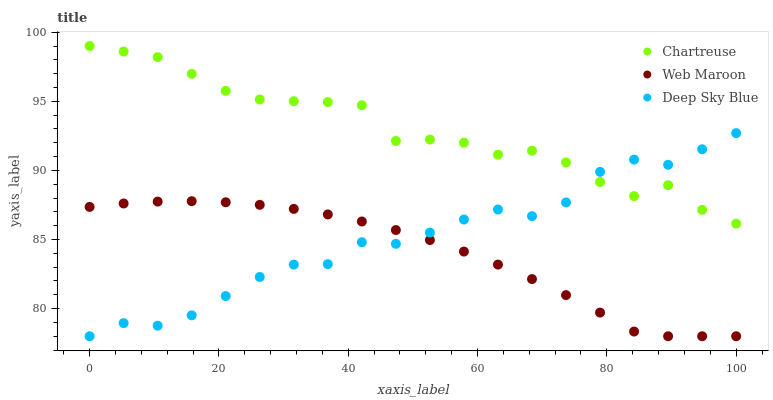Does Web Maroon have the minimum area under the curve?
Answer yes or no. Yes. Does Chartreuse have the maximum area under the curve?
Answer yes or no. Yes. Does Deep Sky Blue have the minimum area under the curve?
Answer yes or no. No. Does Deep Sky Blue have the maximum area under the curve?
Answer yes or no. No. Is Web Maroon the smoothest?
Answer yes or no. Yes. Is Deep Sky Blue the roughest?
Answer yes or no. Yes. Is Deep Sky Blue the smoothest?
Answer yes or no. No. Is Web Maroon the roughest?
Answer yes or no. No. Does Web Maroon have the lowest value?
Answer yes or no. Yes. Does Chartreuse have the highest value?
Answer yes or no. Yes. Does Deep Sky Blue have the highest value?
Answer yes or no. No. Is Web Maroon less than Chartreuse?
Answer yes or no. Yes. Is Chartreuse greater than Web Maroon?
Answer yes or no. Yes. Does Chartreuse intersect Deep Sky Blue?
Answer yes or no. Yes. Is Chartreuse less than Deep Sky Blue?
Answer yes or no. No. Is Chartreuse greater than Deep Sky Blue?
Answer yes or no. No. Does Web Maroon intersect Chartreuse?
Answer yes or no. No. 